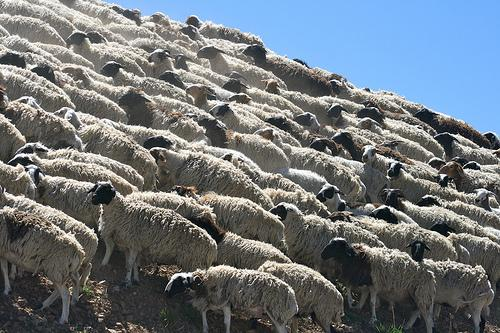Count the total number of sheep with dirty coats in the image. There are six sheep with dirty coats in the image. Mention any observable interaction between the sheep and the environment in the image. The sheep are walking on the brown rocky ground covered with little grass, and some sheep having dirty coats may indicate their interaction with the environment. What subject is dominating the image, and what is their general environment? A large herd of sheep dominates the image, walking up a hill with a clear blue sky in the background and brown rocky ground with little grass beneath them. Comment on the weather and the state of the sky in the image. The weather seems pleasant, and the sky is clear and blue with no clouds. Describe the ground where the sheep are walking. The ground is brown and rocky with little grass, with some twigs and dirt, and a small tuft of green grass. Identify the primary objects in the image and describe their appearance. There are multiple sheep with white and thick coats, some with black and brown heads, and one with a brown head. The sky is blue and clear, and the ground is brown and rocky with little grass. Mention any notable physical features of the sheep in the image. Some sheep have black faces and necks, white faces with black spots, and brown heads; one sheep has a brown spot on its back, and some have dirty coats. Identify any unusual or unique features of the sheep visible in the image. One sheep has a white face and black spots, while another has a brown spot on its back, and some have dirty coats. Describe the posture of the group of sheep in the image. The sheep are gathered together, walking up a hill, with some looking towards the camera. Is there a sheep with a brown face and neck at X:316 Y:240? Although there is a sheep with a black face and neck at these coordinates, there is no mention of a sheep with a brown face and neck. Are there any sheep with purple spots on their backs at X:5 Y:203? No, it's not mentioned in the image. Can you find the sheep with green wool at X:193 Y:265? The image does not have any sheep with green wool. The given coordinates describe wool on a sheep but not green wool. 